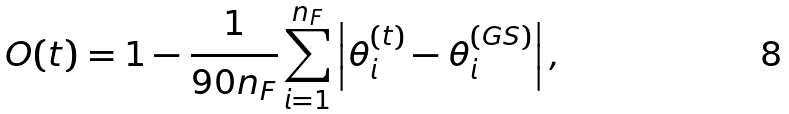<formula> <loc_0><loc_0><loc_500><loc_500>O ( t ) = 1 - \frac { 1 } { 9 0 n _ { F } } \sum _ { i = 1 } ^ { n _ { F } } \left | \theta _ { i } ^ { ( t ) } - \theta _ { i } ^ { ( G S ) } \right | ,</formula> 